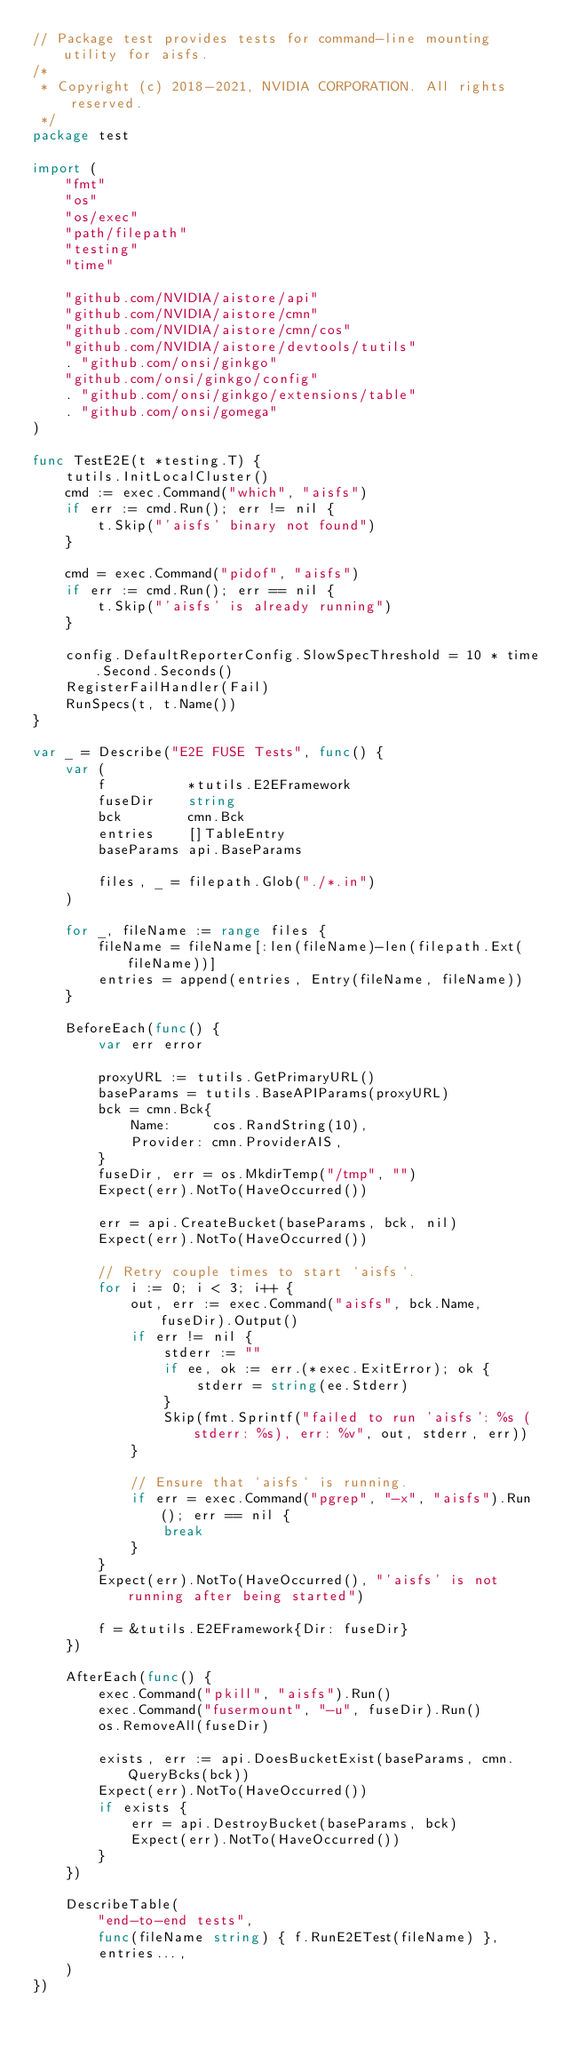Convert code to text. <code><loc_0><loc_0><loc_500><loc_500><_Go_>// Package test provides tests for command-line mounting utility for aisfs.
/*
 * Copyright (c) 2018-2021, NVIDIA CORPORATION. All rights reserved.
 */
package test

import (
	"fmt"
	"os"
	"os/exec"
	"path/filepath"
	"testing"
	"time"

	"github.com/NVIDIA/aistore/api"
	"github.com/NVIDIA/aistore/cmn"
	"github.com/NVIDIA/aistore/cmn/cos"
	"github.com/NVIDIA/aistore/devtools/tutils"
	. "github.com/onsi/ginkgo"
	"github.com/onsi/ginkgo/config"
	. "github.com/onsi/ginkgo/extensions/table"
	. "github.com/onsi/gomega"
)

func TestE2E(t *testing.T) {
	tutils.InitLocalCluster()
	cmd := exec.Command("which", "aisfs")
	if err := cmd.Run(); err != nil {
		t.Skip("'aisfs' binary not found")
	}

	cmd = exec.Command("pidof", "aisfs")
	if err := cmd.Run(); err == nil {
		t.Skip("'aisfs' is already running")
	}

	config.DefaultReporterConfig.SlowSpecThreshold = 10 * time.Second.Seconds()
	RegisterFailHandler(Fail)
	RunSpecs(t, t.Name())
}

var _ = Describe("E2E FUSE Tests", func() {
	var (
		f          *tutils.E2EFramework
		fuseDir    string
		bck        cmn.Bck
		entries    []TableEntry
		baseParams api.BaseParams

		files, _ = filepath.Glob("./*.in")
	)

	for _, fileName := range files {
		fileName = fileName[:len(fileName)-len(filepath.Ext(fileName))]
		entries = append(entries, Entry(fileName, fileName))
	}

	BeforeEach(func() {
		var err error

		proxyURL := tutils.GetPrimaryURL()
		baseParams = tutils.BaseAPIParams(proxyURL)
		bck = cmn.Bck{
			Name:     cos.RandString(10),
			Provider: cmn.ProviderAIS,
		}
		fuseDir, err = os.MkdirTemp("/tmp", "")
		Expect(err).NotTo(HaveOccurred())

		err = api.CreateBucket(baseParams, bck, nil)
		Expect(err).NotTo(HaveOccurred())

		// Retry couple times to start `aisfs`.
		for i := 0; i < 3; i++ {
			out, err := exec.Command("aisfs", bck.Name, fuseDir).Output()
			if err != nil {
				stderr := ""
				if ee, ok := err.(*exec.ExitError); ok {
					stderr = string(ee.Stderr)
				}
				Skip(fmt.Sprintf("failed to run 'aisfs': %s (stderr: %s), err: %v", out, stderr, err))
			}

			// Ensure that `aisfs` is running.
			if err = exec.Command("pgrep", "-x", "aisfs").Run(); err == nil {
				break
			}
		}
		Expect(err).NotTo(HaveOccurred(), "'aisfs' is not running after being started")

		f = &tutils.E2EFramework{Dir: fuseDir}
	})

	AfterEach(func() {
		exec.Command("pkill", "aisfs").Run()
		exec.Command("fusermount", "-u", fuseDir).Run()
		os.RemoveAll(fuseDir)

		exists, err := api.DoesBucketExist(baseParams, cmn.QueryBcks(bck))
		Expect(err).NotTo(HaveOccurred())
		if exists {
			err = api.DestroyBucket(baseParams, bck)
			Expect(err).NotTo(HaveOccurred())
		}
	})

	DescribeTable(
		"end-to-end tests",
		func(fileName string) { f.RunE2ETest(fileName) },
		entries...,
	)
})
</code> 